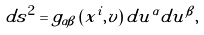<formula> <loc_0><loc_0><loc_500><loc_500>d s ^ { 2 } = { g } _ { \alpha \beta } \left ( x ^ { i } , v \right ) d u ^ { \alpha } d u ^ { \beta } ,</formula> 